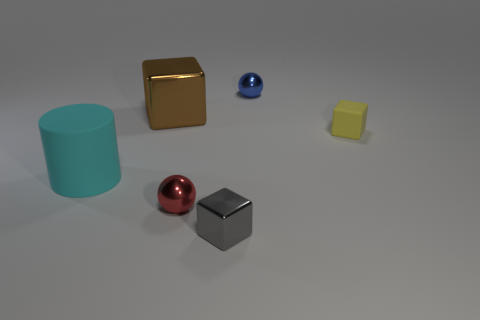Is the big cyan cylinder made of the same material as the tiny yellow object?
Provide a short and direct response. Yes. How many things are both to the right of the red shiny thing and behind the yellow rubber block?
Your answer should be very brief. 1. What number of other objects are there of the same material as the yellow object?
Your response must be concise. 1. There is a blue metallic thing that is the same shape as the tiny red shiny object; what size is it?
Your answer should be compact. Small. Do the tiny sphere to the right of the gray block and the big thing that is behind the large rubber cylinder have the same material?
Your answer should be very brief. Yes. Are there any other things that are the same shape as the big matte object?
Give a very brief answer. No. There is another tiny matte object that is the same shape as the gray object; what is its color?
Ensure brevity in your answer.  Yellow. Does the metallic cube to the right of the red sphere have the same size as the matte block?
Your answer should be compact. Yes. There is a cyan object that is in front of the small ball that is to the right of the gray cube; how big is it?
Ensure brevity in your answer.  Large. Is the cyan thing made of the same material as the thing behind the large shiny object?
Offer a very short reply. No. 